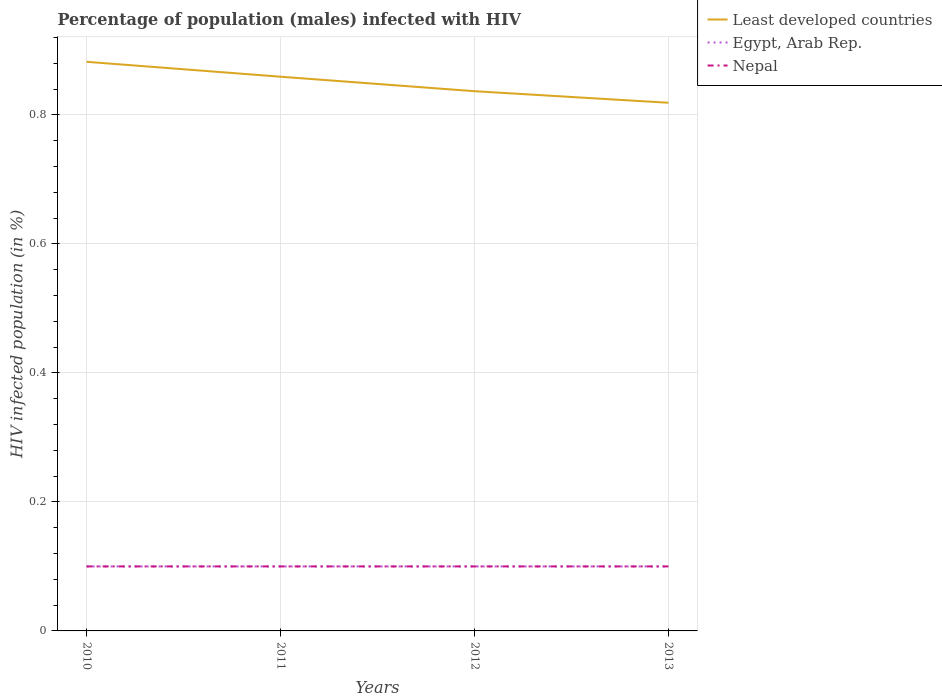How many different coloured lines are there?
Offer a terse response. 3. Does the line corresponding to Nepal intersect with the line corresponding to Least developed countries?
Keep it short and to the point. No. Across all years, what is the maximum percentage of HIV infected male population in Least developed countries?
Provide a succinct answer. 0.82. What is the total percentage of HIV infected male population in Least developed countries in the graph?
Make the answer very short. 0.02. What is the difference between the highest and the second highest percentage of HIV infected male population in Nepal?
Keep it short and to the point. 0. What is the difference between the highest and the lowest percentage of HIV infected male population in Least developed countries?
Provide a succinct answer. 2. How many lines are there?
Give a very brief answer. 3. How many years are there in the graph?
Provide a succinct answer. 4. What is the difference between two consecutive major ticks on the Y-axis?
Provide a short and direct response. 0.2. Are the values on the major ticks of Y-axis written in scientific E-notation?
Offer a very short reply. No. Does the graph contain grids?
Your answer should be very brief. Yes. How many legend labels are there?
Offer a very short reply. 3. What is the title of the graph?
Give a very brief answer. Percentage of population (males) infected with HIV. Does "New Zealand" appear as one of the legend labels in the graph?
Offer a terse response. No. What is the label or title of the X-axis?
Your response must be concise. Years. What is the label or title of the Y-axis?
Ensure brevity in your answer.  HIV infected population (in %). What is the HIV infected population (in %) in Least developed countries in 2010?
Your answer should be very brief. 0.88. What is the HIV infected population (in %) of Egypt, Arab Rep. in 2010?
Your response must be concise. 0.1. What is the HIV infected population (in %) in Least developed countries in 2011?
Keep it short and to the point. 0.86. What is the HIV infected population (in %) in Egypt, Arab Rep. in 2011?
Your answer should be compact. 0.1. What is the HIV infected population (in %) of Least developed countries in 2012?
Your answer should be compact. 0.84. What is the HIV infected population (in %) of Nepal in 2012?
Keep it short and to the point. 0.1. What is the HIV infected population (in %) in Least developed countries in 2013?
Make the answer very short. 0.82. What is the HIV infected population (in %) in Egypt, Arab Rep. in 2013?
Make the answer very short. 0.1. What is the HIV infected population (in %) of Nepal in 2013?
Your response must be concise. 0.1. Across all years, what is the maximum HIV infected population (in %) in Least developed countries?
Your answer should be very brief. 0.88. Across all years, what is the maximum HIV infected population (in %) of Egypt, Arab Rep.?
Provide a succinct answer. 0.1. Across all years, what is the minimum HIV infected population (in %) in Least developed countries?
Your response must be concise. 0.82. Across all years, what is the minimum HIV infected population (in %) in Egypt, Arab Rep.?
Ensure brevity in your answer.  0.1. What is the total HIV infected population (in %) in Least developed countries in the graph?
Give a very brief answer. 3.4. What is the total HIV infected population (in %) in Egypt, Arab Rep. in the graph?
Keep it short and to the point. 0.4. What is the total HIV infected population (in %) of Nepal in the graph?
Your response must be concise. 0.4. What is the difference between the HIV infected population (in %) in Least developed countries in 2010 and that in 2011?
Offer a very short reply. 0.02. What is the difference between the HIV infected population (in %) of Egypt, Arab Rep. in 2010 and that in 2011?
Offer a terse response. 0. What is the difference between the HIV infected population (in %) in Least developed countries in 2010 and that in 2012?
Provide a short and direct response. 0.05. What is the difference between the HIV infected population (in %) in Least developed countries in 2010 and that in 2013?
Your answer should be very brief. 0.06. What is the difference between the HIV infected population (in %) in Least developed countries in 2011 and that in 2012?
Offer a very short reply. 0.02. What is the difference between the HIV infected population (in %) in Egypt, Arab Rep. in 2011 and that in 2012?
Offer a terse response. 0. What is the difference between the HIV infected population (in %) in Nepal in 2011 and that in 2012?
Your answer should be compact. 0. What is the difference between the HIV infected population (in %) in Least developed countries in 2011 and that in 2013?
Offer a very short reply. 0.04. What is the difference between the HIV infected population (in %) in Least developed countries in 2012 and that in 2013?
Your answer should be compact. 0.02. What is the difference between the HIV infected population (in %) in Egypt, Arab Rep. in 2012 and that in 2013?
Provide a short and direct response. 0. What is the difference between the HIV infected population (in %) of Nepal in 2012 and that in 2013?
Provide a succinct answer. 0. What is the difference between the HIV infected population (in %) in Least developed countries in 2010 and the HIV infected population (in %) in Egypt, Arab Rep. in 2011?
Provide a succinct answer. 0.78. What is the difference between the HIV infected population (in %) of Least developed countries in 2010 and the HIV infected population (in %) of Nepal in 2011?
Your answer should be very brief. 0.78. What is the difference between the HIV infected population (in %) of Egypt, Arab Rep. in 2010 and the HIV infected population (in %) of Nepal in 2011?
Offer a terse response. 0. What is the difference between the HIV infected population (in %) in Least developed countries in 2010 and the HIV infected population (in %) in Egypt, Arab Rep. in 2012?
Give a very brief answer. 0.78. What is the difference between the HIV infected population (in %) in Least developed countries in 2010 and the HIV infected population (in %) in Nepal in 2012?
Make the answer very short. 0.78. What is the difference between the HIV infected population (in %) in Least developed countries in 2010 and the HIV infected population (in %) in Egypt, Arab Rep. in 2013?
Keep it short and to the point. 0.78. What is the difference between the HIV infected population (in %) in Least developed countries in 2010 and the HIV infected population (in %) in Nepal in 2013?
Ensure brevity in your answer.  0.78. What is the difference between the HIV infected population (in %) in Least developed countries in 2011 and the HIV infected population (in %) in Egypt, Arab Rep. in 2012?
Provide a short and direct response. 0.76. What is the difference between the HIV infected population (in %) in Least developed countries in 2011 and the HIV infected population (in %) in Nepal in 2012?
Keep it short and to the point. 0.76. What is the difference between the HIV infected population (in %) in Least developed countries in 2011 and the HIV infected population (in %) in Egypt, Arab Rep. in 2013?
Your answer should be very brief. 0.76. What is the difference between the HIV infected population (in %) in Least developed countries in 2011 and the HIV infected population (in %) in Nepal in 2013?
Give a very brief answer. 0.76. What is the difference between the HIV infected population (in %) of Least developed countries in 2012 and the HIV infected population (in %) of Egypt, Arab Rep. in 2013?
Your answer should be compact. 0.74. What is the difference between the HIV infected population (in %) in Least developed countries in 2012 and the HIV infected population (in %) in Nepal in 2013?
Offer a terse response. 0.74. What is the average HIV infected population (in %) in Least developed countries per year?
Provide a short and direct response. 0.85. What is the average HIV infected population (in %) in Egypt, Arab Rep. per year?
Give a very brief answer. 0.1. In the year 2010, what is the difference between the HIV infected population (in %) in Least developed countries and HIV infected population (in %) in Egypt, Arab Rep.?
Give a very brief answer. 0.78. In the year 2010, what is the difference between the HIV infected population (in %) of Least developed countries and HIV infected population (in %) of Nepal?
Your answer should be very brief. 0.78. In the year 2011, what is the difference between the HIV infected population (in %) of Least developed countries and HIV infected population (in %) of Egypt, Arab Rep.?
Your response must be concise. 0.76. In the year 2011, what is the difference between the HIV infected population (in %) of Least developed countries and HIV infected population (in %) of Nepal?
Keep it short and to the point. 0.76. In the year 2012, what is the difference between the HIV infected population (in %) of Least developed countries and HIV infected population (in %) of Egypt, Arab Rep.?
Give a very brief answer. 0.74. In the year 2012, what is the difference between the HIV infected population (in %) in Least developed countries and HIV infected population (in %) in Nepal?
Your answer should be compact. 0.74. In the year 2013, what is the difference between the HIV infected population (in %) in Least developed countries and HIV infected population (in %) in Egypt, Arab Rep.?
Your answer should be very brief. 0.72. In the year 2013, what is the difference between the HIV infected population (in %) of Least developed countries and HIV infected population (in %) of Nepal?
Your answer should be very brief. 0.72. In the year 2013, what is the difference between the HIV infected population (in %) in Egypt, Arab Rep. and HIV infected population (in %) in Nepal?
Your response must be concise. 0. What is the ratio of the HIV infected population (in %) of Least developed countries in 2010 to that in 2011?
Your answer should be compact. 1.03. What is the ratio of the HIV infected population (in %) in Nepal in 2010 to that in 2011?
Make the answer very short. 1. What is the ratio of the HIV infected population (in %) of Least developed countries in 2010 to that in 2012?
Offer a terse response. 1.05. What is the ratio of the HIV infected population (in %) of Least developed countries in 2010 to that in 2013?
Give a very brief answer. 1.08. What is the ratio of the HIV infected population (in %) in Least developed countries in 2011 to that in 2012?
Offer a very short reply. 1.03. What is the ratio of the HIV infected population (in %) in Least developed countries in 2011 to that in 2013?
Provide a succinct answer. 1.05. What is the ratio of the HIV infected population (in %) of Nepal in 2011 to that in 2013?
Keep it short and to the point. 1. What is the ratio of the HIV infected population (in %) of Least developed countries in 2012 to that in 2013?
Give a very brief answer. 1.02. What is the ratio of the HIV infected population (in %) in Egypt, Arab Rep. in 2012 to that in 2013?
Offer a terse response. 1. What is the ratio of the HIV infected population (in %) of Nepal in 2012 to that in 2013?
Provide a short and direct response. 1. What is the difference between the highest and the second highest HIV infected population (in %) in Least developed countries?
Make the answer very short. 0.02. What is the difference between the highest and the second highest HIV infected population (in %) of Nepal?
Your response must be concise. 0. What is the difference between the highest and the lowest HIV infected population (in %) in Least developed countries?
Ensure brevity in your answer.  0.06. What is the difference between the highest and the lowest HIV infected population (in %) in Nepal?
Provide a short and direct response. 0. 